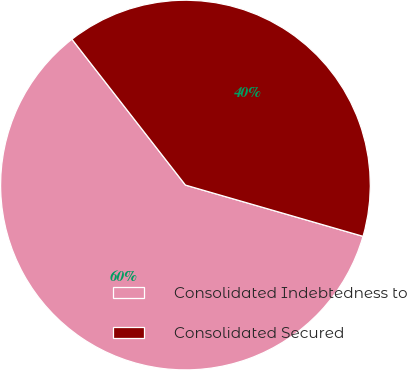<chart> <loc_0><loc_0><loc_500><loc_500><pie_chart><fcel>Consolidated Indebtedness to<fcel>Consolidated Secured<nl><fcel>60.0%<fcel>40.0%<nl></chart> 